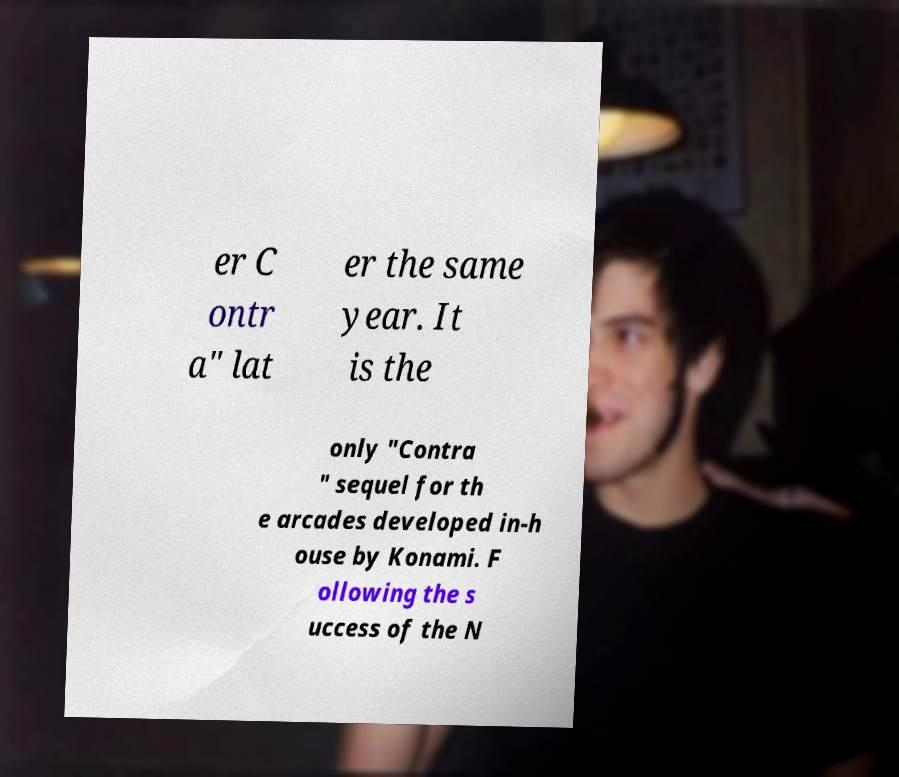I need the written content from this picture converted into text. Can you do that? er C ontr a" lat er the same year. It is the only "Contra " sequel for th e arcades developed in-h ouse by Konami. F ollowing the s uccess of the N 